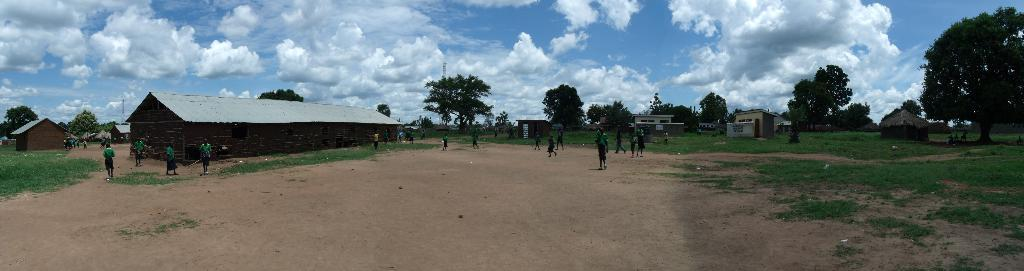What can be seen in the image? There are people standing in the image, along with wooden houses, trees, towers, and the sky. Where are the people standing? The people are standing on the ground. What type of structures are present in the image? There are wooden houses and towers in the image. What is visible in the background of the image? The sky is visible in the background of the image, with clouds present. What type of substance is being used by the people to clean their hands in the image? There is no indication of any substance being used for cleaning hands in the image. 